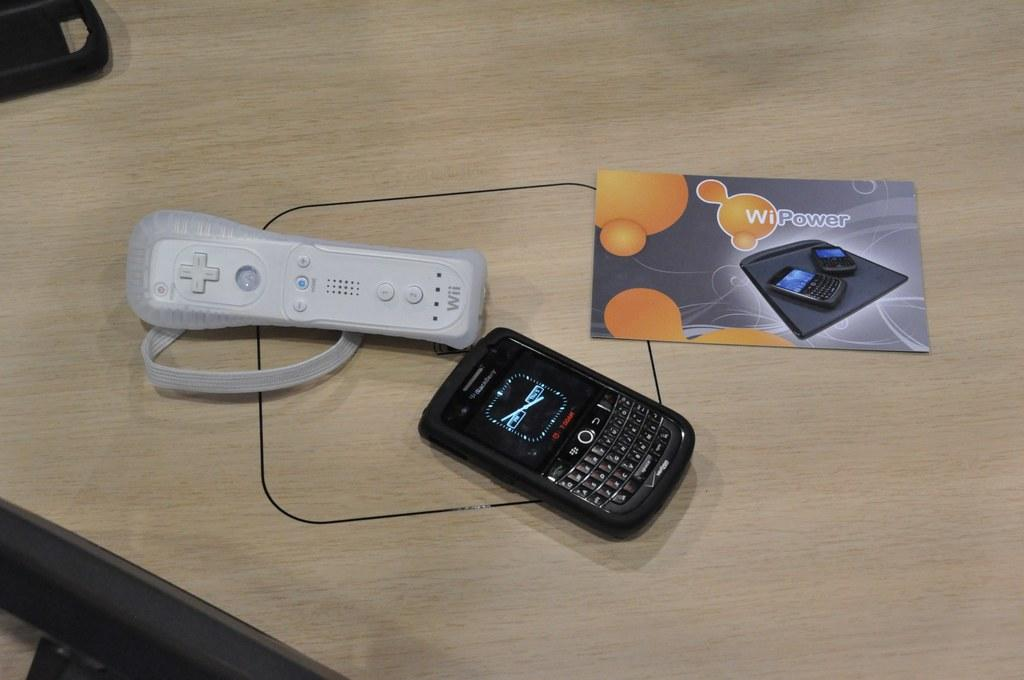<image>
Give a short and clear explanation of the subsequent image. A black cell phone is next to a Nintendo Wii controller on a table. 